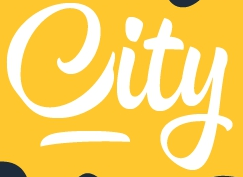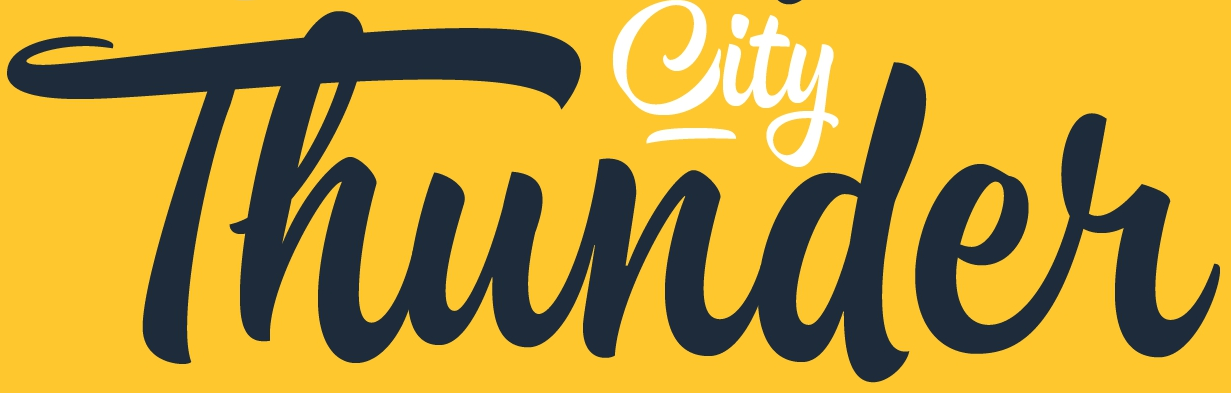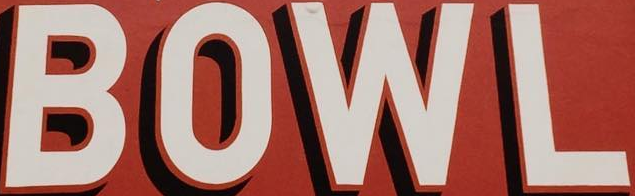Read the text content from these images in order, separated by a semicolon. City; Thunder; BOWL 